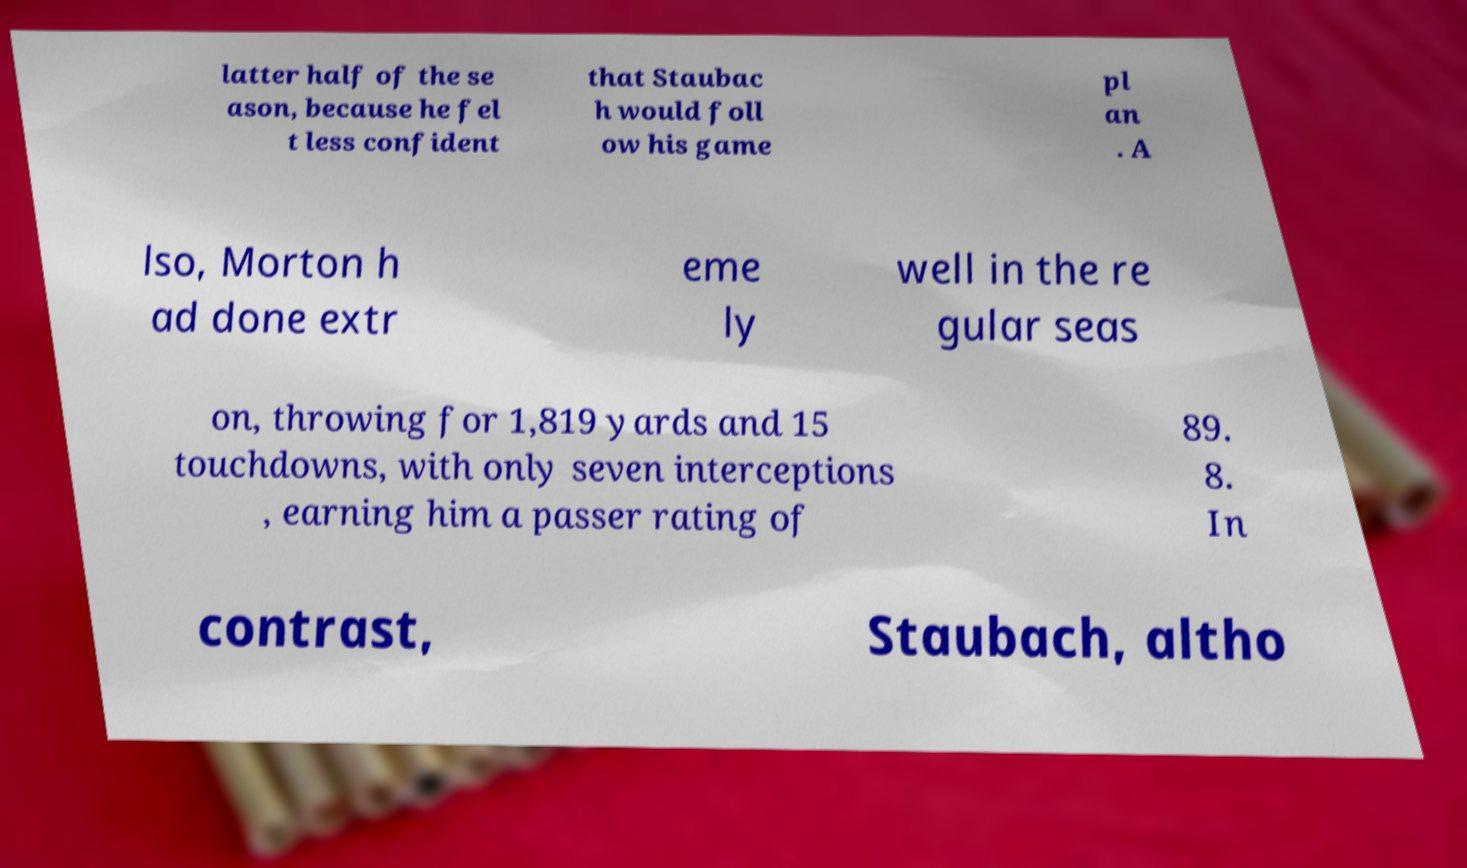I need the written content from this picture converted into text. Can you do that? latter half of the se ason, because he fel t less confident that Staubac h would foll ow his game pl an . A lso, Morton h ad done extr eme ly well in the re gular seas on, throwing for 1,819 yards and 15 touchdowns, with only seven interceptions , earning him a passer rating of 89. 8. In contrast, Staubach, altho 